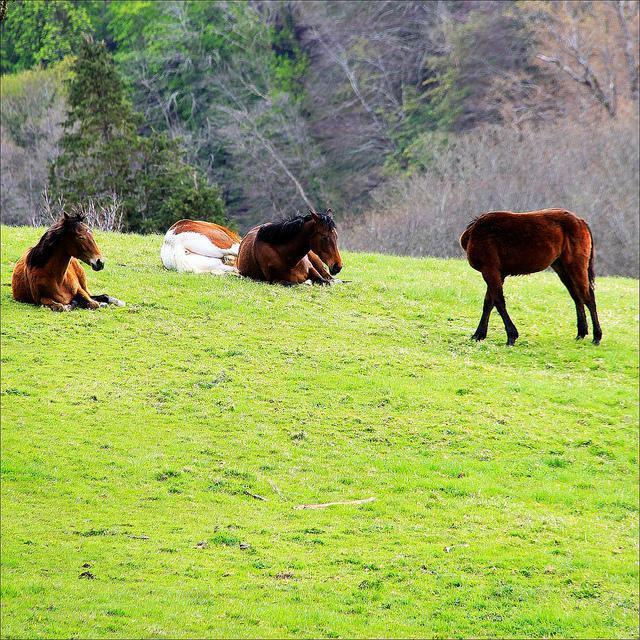Which of these horses would stand out in a dark setting?
Select the correct answer and articulate reasoning with the following format: 'Answer: answer
Rationale: rationale.'
Options: Far left, second right, second left, far right. Answer: second left.
Rationale: The second left horse is white. 